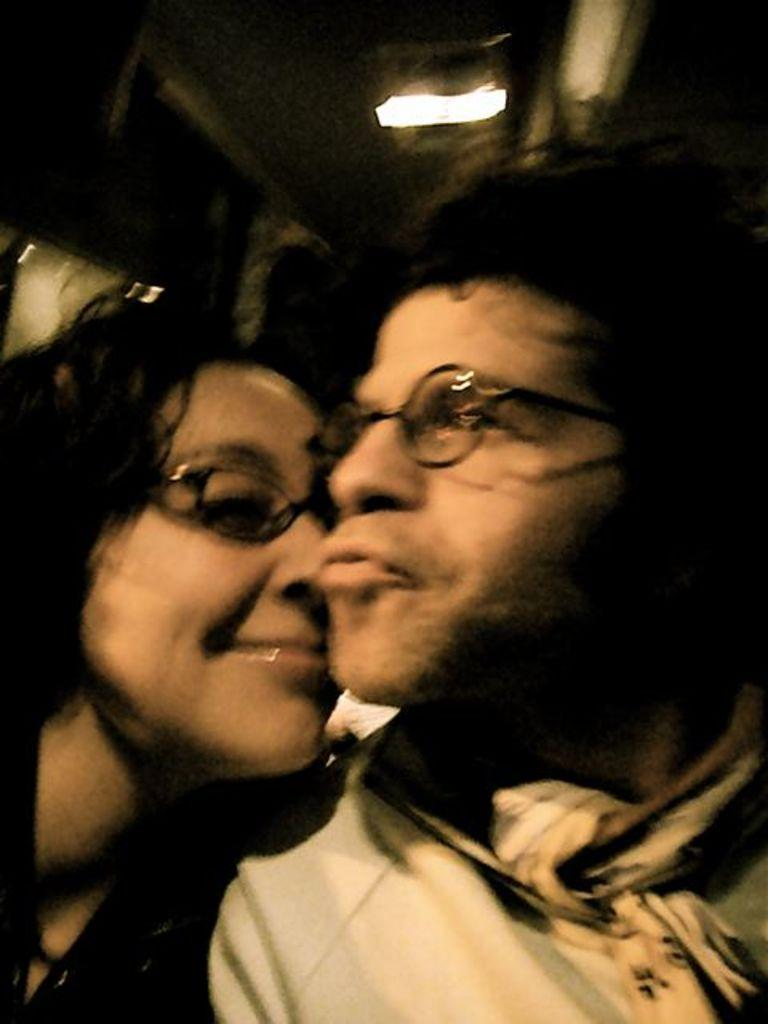Who is present in the image? There is a couple in the image. What can be observed about the couple's appearance? Both individuals in the couple are wearing spectacles. Can you describe the quality of the image? The image is partially blurred. What can be seen in the background of the image? There is a light visible in the background of the image. What type of flowers can be seen growing on the owl's head in the image? There is no owl or flowers present in the image; it features a couple wearing spectacles. 